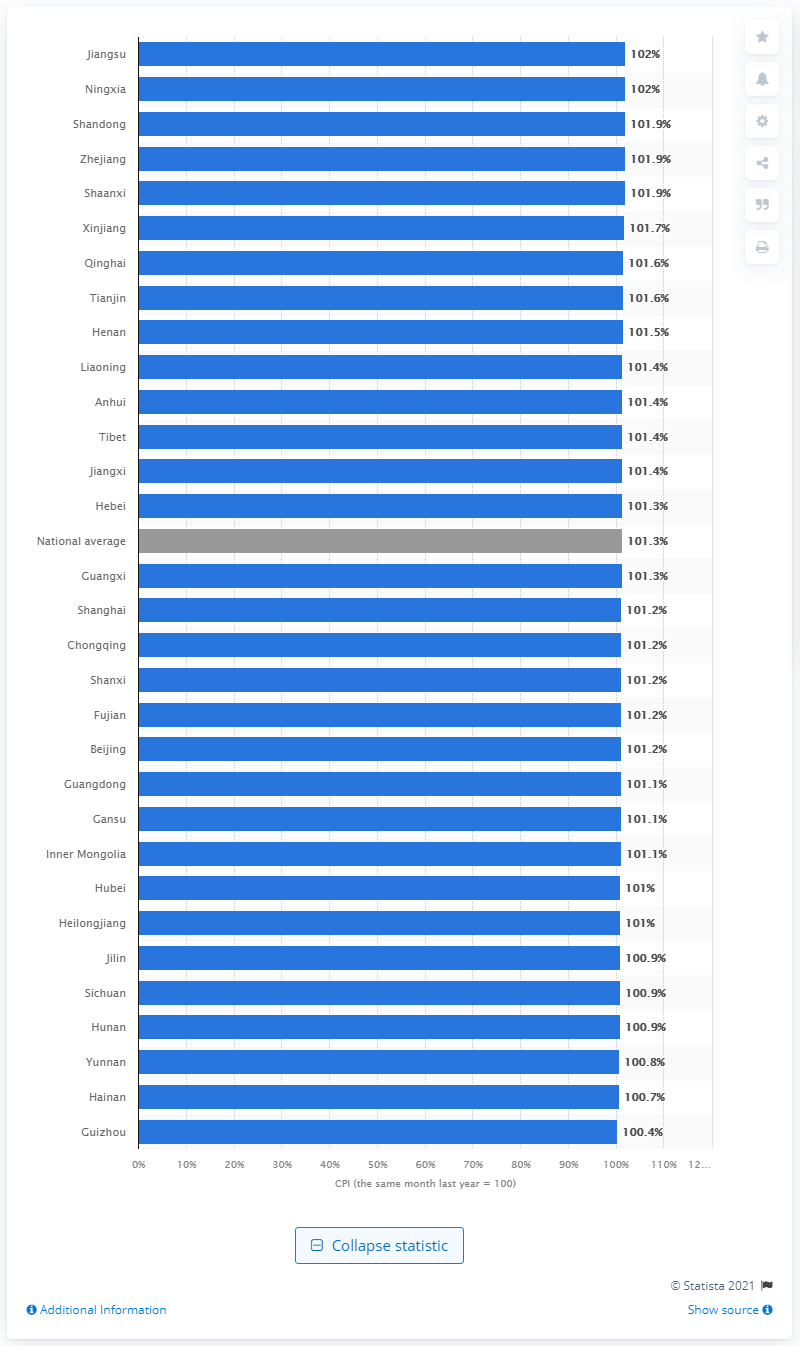Give some essential details in this illustration. The Consumer Price Index (CPI) reached 102 points in the province of Jiangsu. 